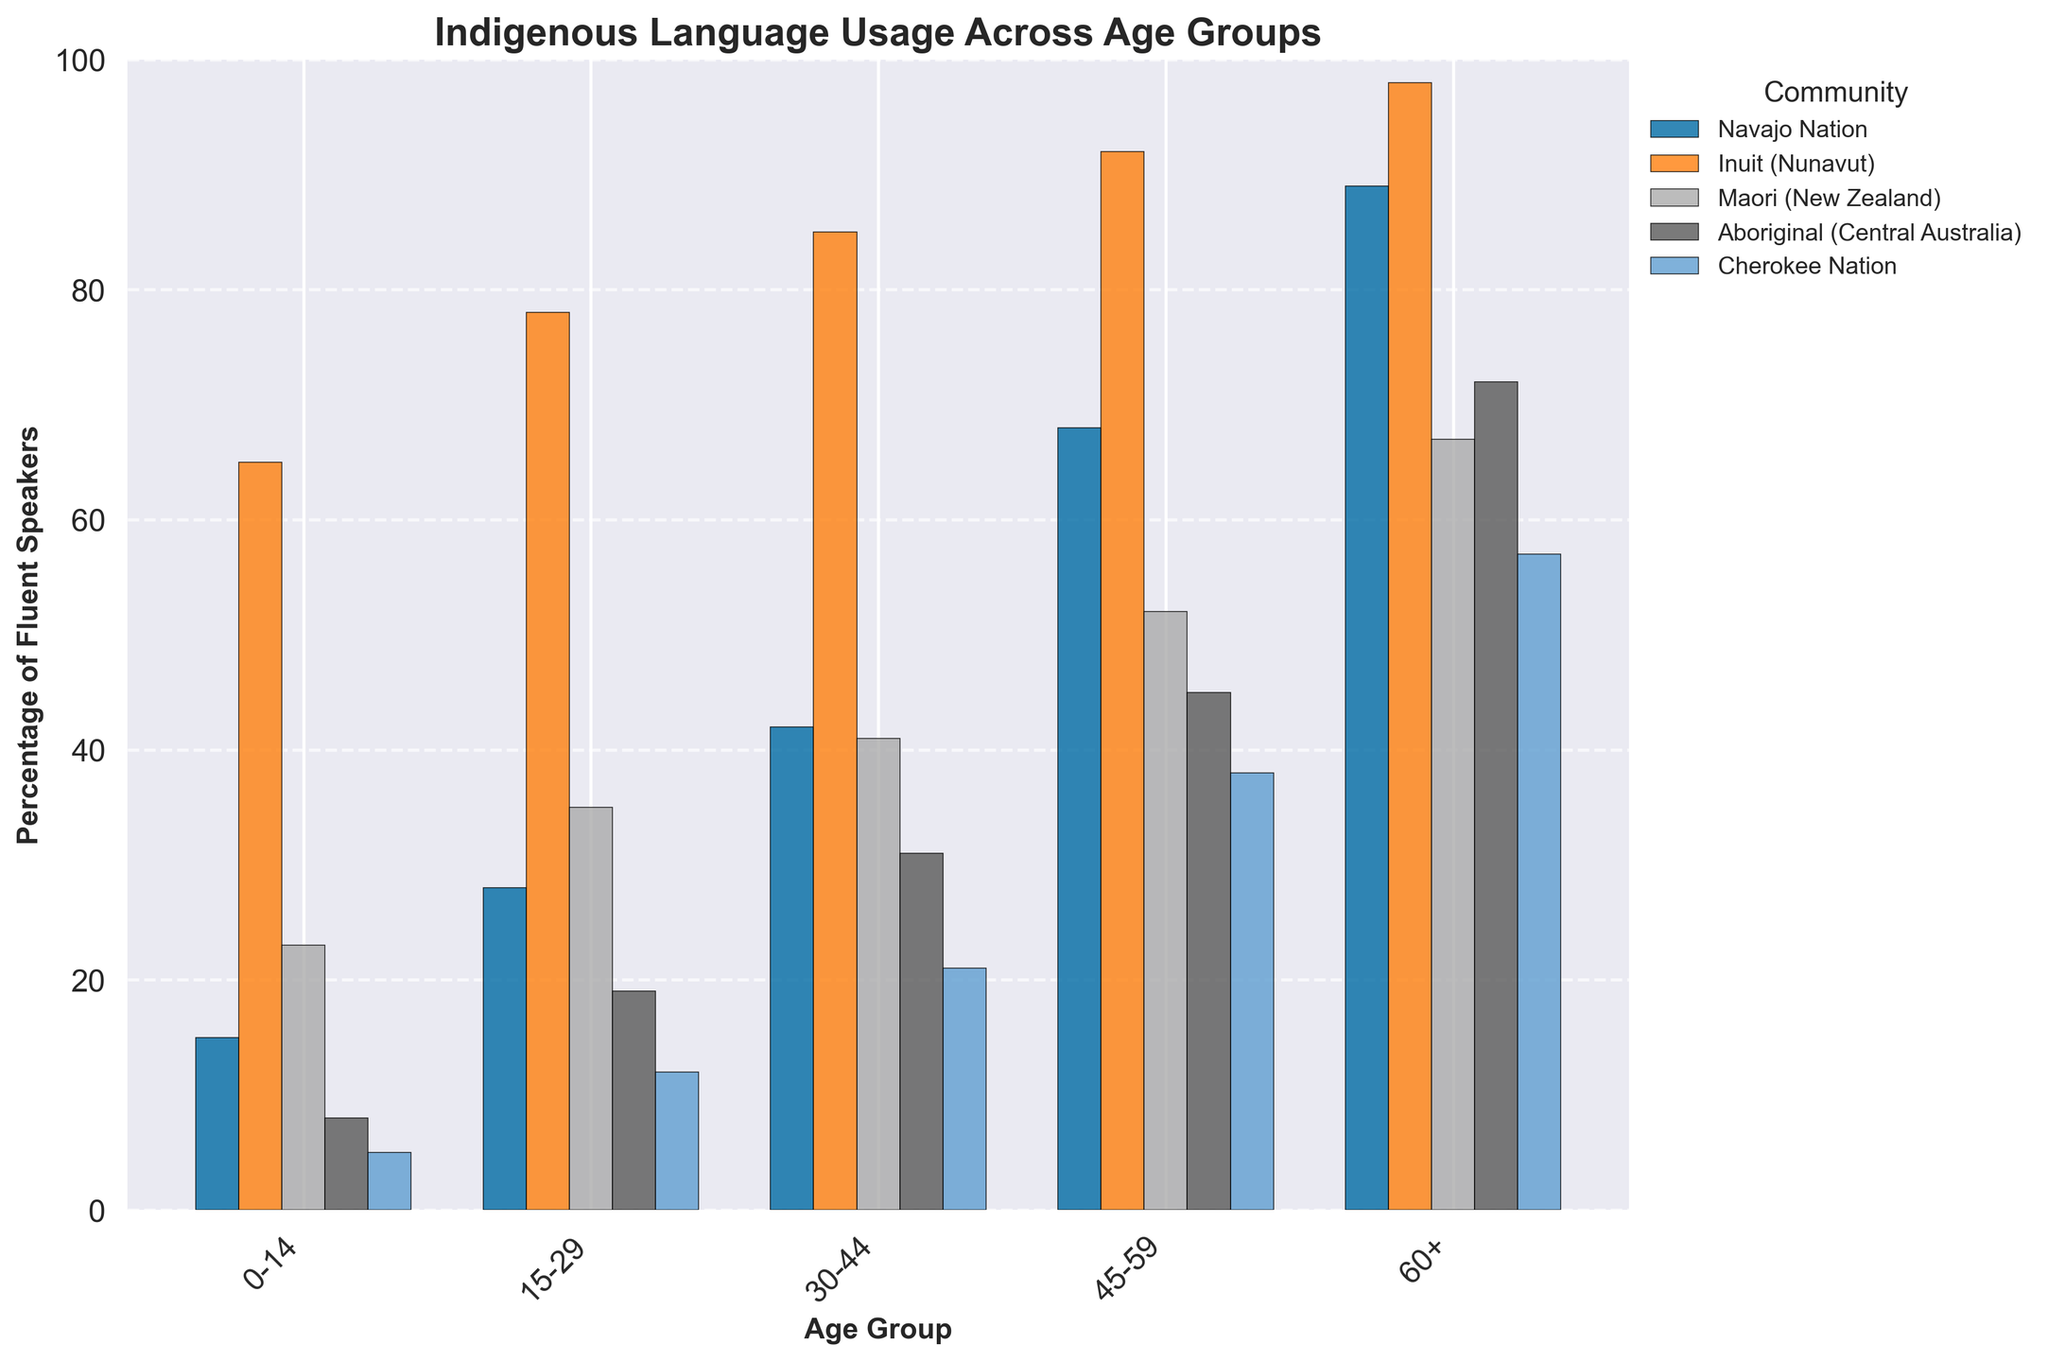Which community has the highest percentage of fluent speakers in the 0-14 age group? To determine this, observe the height of the bars representing each community in the graph under the 0-14 age group category. The Inuit (Nunavut) community has the tallest bar in this age group.
Answer: Inuit (Nunavut) Compare the percentage of fluent speakers aged 30-44 between the Navajo Nation and the Maori (New Zealand). Look at the bars corresponding to the 30-44 age group for both the Navajo Nation and Maori (New Zealand) and compare their heights. The Navajo Nation has a bar height of 42%, whereas the Maori (New Zealand) has a bar height of 41%. Therefore, the Navajo Nation has a slightly higher percentage of fluent speakers in this age group.
Answer: Navajo Nation What is the difference in the percentage of fluent speakers aged 60+ between the Aboriginal (Central Australia) and Cherokee Nation? Identify the bar heights for both communities in the 60+ age group. The Aboriginal (Central Australia) has a bar height of 72%, and the Cherokee Nation has a bar height of 57%. Subtract 57 from 72 to get 15.
Answer: 15% Which age group has the highest percentage of fluent speakers among the Maori (New Zealand) community? Look for the maximum bar height among the series representing Maori (New Zealand) across different age groups. The height increases progressively, with the highest percentage being in the 60+ age group at 67%.
Answer: 60+ How does the percentage of fluent speakers aged 45-59 in the Inuit (Nunavut) community compare to that in the overall 60+ age group across all communities? The bar for the Inuit (Nunavut) aged 45-59 has a height of 92%. For the overall 60+ age group, determine the individual percentages: Navajo Nation (89%), Inuit (Nunavut) (98%), Maori (New Zealand) (67%), Aboriginal (Central Australia) (72%), Cherokee Nation (57%). Out of these, 89% and 98% are higher than 92%. Therefore, the percentage for Inuit (Nunavut) aged 45-59 is less than the highest percentage in the 60+ age group, which is 98%.
Answer: The Inuit (Nunavut) percentage for ages 45-59 is lower than the highest percentage in the overall 60+ age group What is the average percentage of fluent speakers aged 15-29 across all communities? Add the percentages for the 15-29 age group across all communities and divide by the number of communities. The values are 28% (Navajo Nation), 78% (Inuit (Nunavut)), 35% (Maori (New Zealand)), 19% (Aboriginal (Central Australia)), and 12% (Cherokee Nation). Sum them (28 + 78 + 35 + 19 + 12 = 172) and divide by 5 (172 / 5).
Answer: 34.4% Which community shows the largest increase in the percentage of fluent speakers between the age groups 0-14 and 15-29? Compute the differences in percentages for each community between these age groups: Navajo Nation (28% - 15% = 13%), Inuit (Nunavut) (78% - 65% = 13%), Maori (New Zealand) (35% - 23% = 12%), Aboriginal (Central Australia) (19% - 8% = 11%), Cherokee Nation (12% - 5% = 7%). Both Navajo Nation and Inuit (Nunavut) show the largest increase with 13%.
Answer: Navajo Nation and Inuit (Nunavut) How does the height of the bars for the Inuit (Nunavut) community change across different age groups? Follow the trend in bar heights for the Inuit (Nunavut) community from 0-14 to 60+: the bars progressively increase in height — starting from 65%, then 78%, 85%, 92%, and finally 98%.
Answer: They consistently increase Compare the visual attributes of the bars representing the Aboriginal (Central Australia) community in the 30-44 and 45-59 age groups. Compare the height and positioning of the bars representing Aboriginal (Central Australia) for the specified age groups: the 30-44 age group bar has a height of 31%, while the 45-59 age group bar stands taller at 45%.
Answer: The bar for 45-59 is taller What is the average percentage of fluent speakers across all age groups for the Navajo Nation? Sum the percentages for all age groups in the Navajo Nation and divide by the number of age groups. The values are 15%, 28%, 42%, 68%, and 89%. Sum them (15 + 28 + 42 + 68 + 89 = 242) and divide by 5 (242 / 5).
Answer: 48.4% 